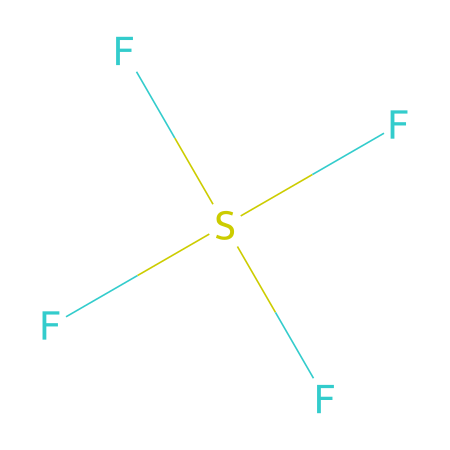What is the molecular formula of sulfur tetrafluoride? The SMILES representation indicates there is one sulfur (S) atom and four fluorine (F) atoms, leading to the molecular formula SF4.
Answer: SF4 How many lone pairs does sulfur have in this compound? To determine the number of lone pairs, we consider the valence electrons of sulfur. Sulfur has six valence electrons; in SF4, it forms four bonds with fluorine. Therefore, there are two remaining valence electrons, equating to one lone pair.
Answer: one What type of hybridization is present in sulfur tetrafluoride? Considering the bonding and lone pairs around the sulfur atom, it adopts sp3d hybridization to accommodate four bonding pairs and one lone pair.
Answer: sp3d What is the molecular geometry of sulfur tetrafluoride? Based on the presence of four bonded fluorine atoms and one lone pair on sulfur, the molecular geometry is based on a seesaw arrangement.
Answer: seesaw Is sulfur tetrafluoride a polar or nonpolar molecule? The molecule has a seesaw shape, leading to an asymmetrical distribution of charge due to the different electronegativities of sulfur and fluorine. Therefore, it is polar.
Answer: polar How is sulfur tetrafluoride commonly used in organic chemistry? Sulfur tetrafluoride is primarily employed as a fluorinating agent, facilitating the introduction of fluorine into organic substrates during chemical reactions.
Answer: fluorinating agent What is the significance of hypervalence in sulfur tetrafluoride? The concept of hypervalence allows sulfur to expand its octet and bond with more than eight electrons, as seen with four fluorine atoms, which is a characteristic of heavy main group elements.
Answer: hypervalence 